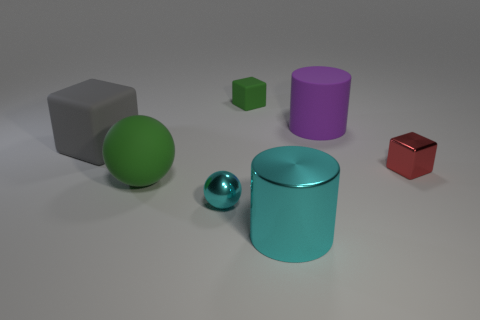Add 1 rubber cylinders. How many objects exist? 8 Subtract all spheres. How many objects are left? 5 Add 1 large shiny things. How many large shiny things are left? 2 Add 7 tiny green cubes. How many tiny green cubes exist? 8 Subtract 1 purple cylinders. How many objects are left? 6 Subtract all small matte cylinders. Subtract all large rubber spheres. How many objects are left? 6 